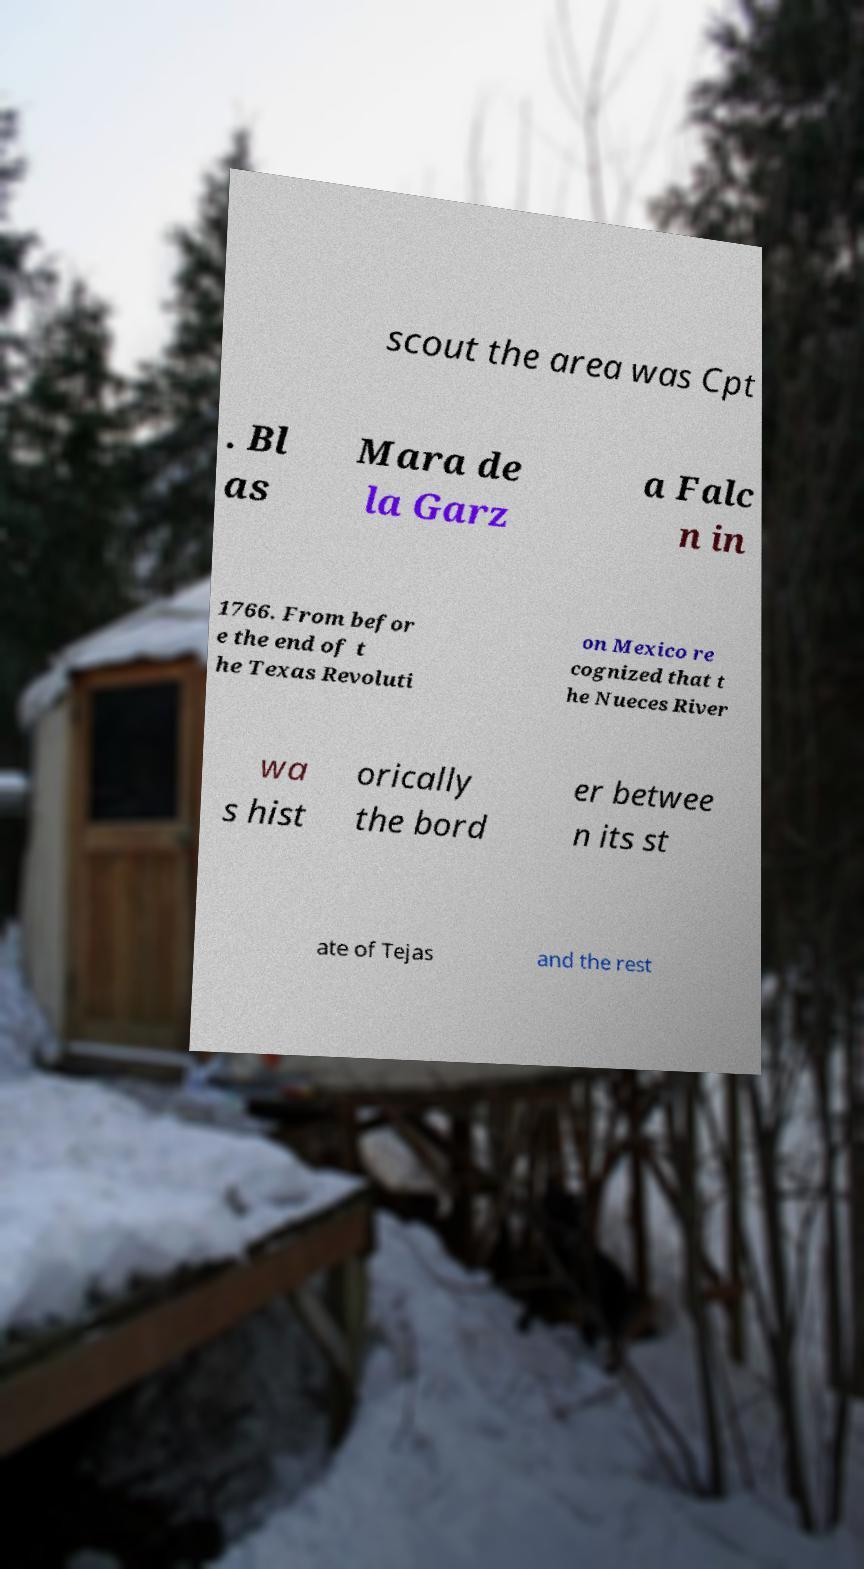I need the written content from this picture converted into text. Can you do that? scout the area was Cpt . Bl as Mara de la Garz a Falc n in 1766. From befor e the end of t he Texas Revoluti on Mexico re cognized that t he Nueces River wa s hist orically the bord er betwee n its st ate of Tejas and the rest 